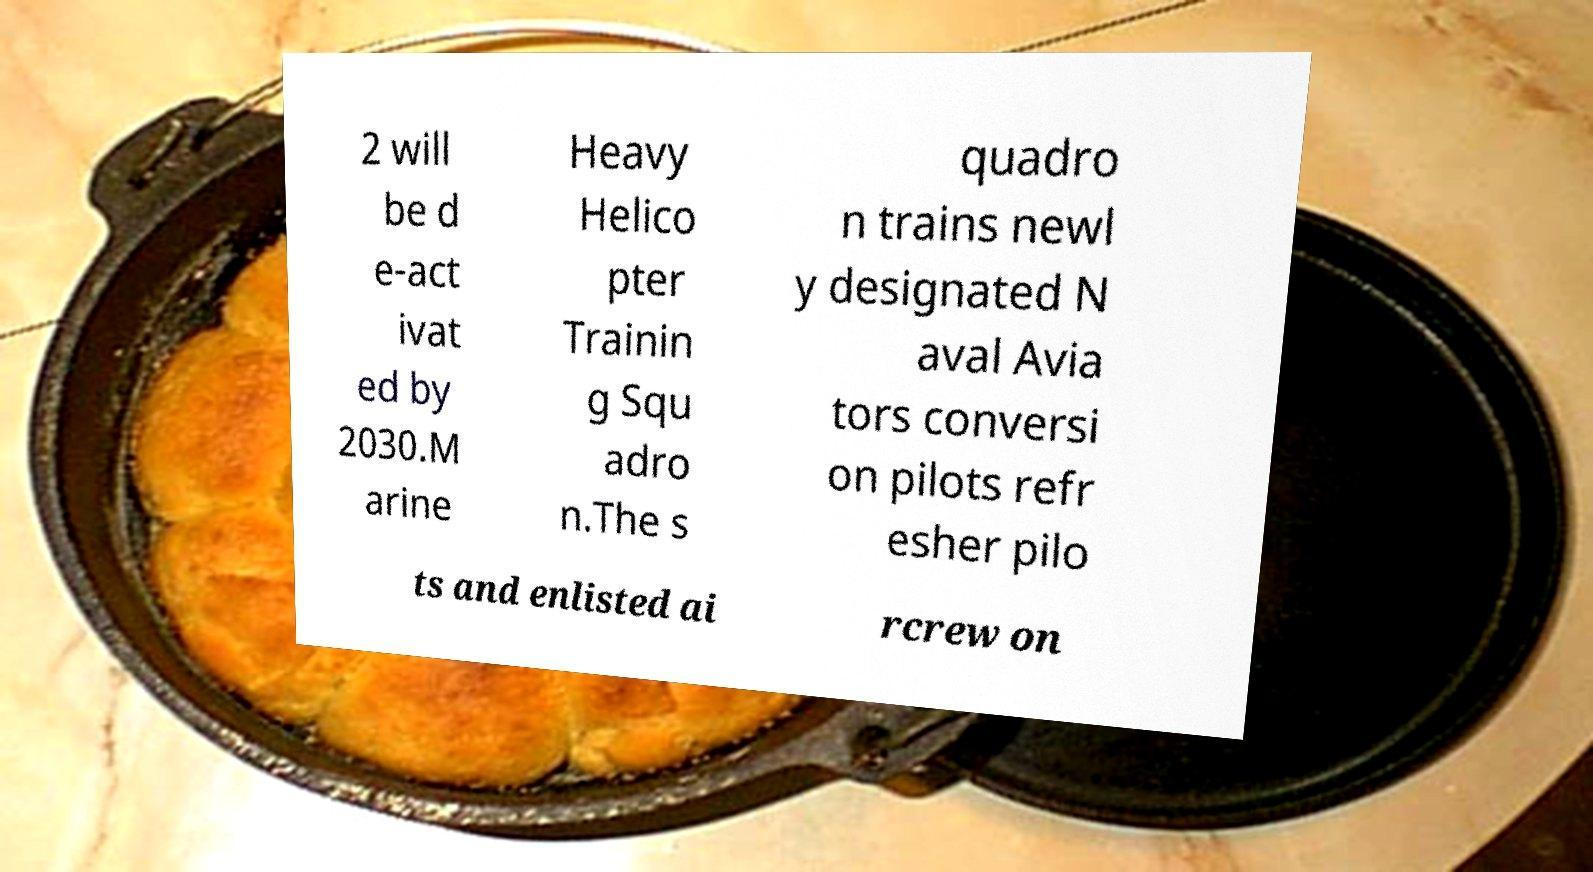For documentation purposes, I need the text within this image transcribed. Could you provide that? 2 will be d e-act ivat ed by 2030.M arine Heavy Helico pter Trainin g Squ adro n.The s quadro n trains newl y designated N aval Avia tors conversi on pilots refr esher pilo ts and enlisted ai rcrew on 